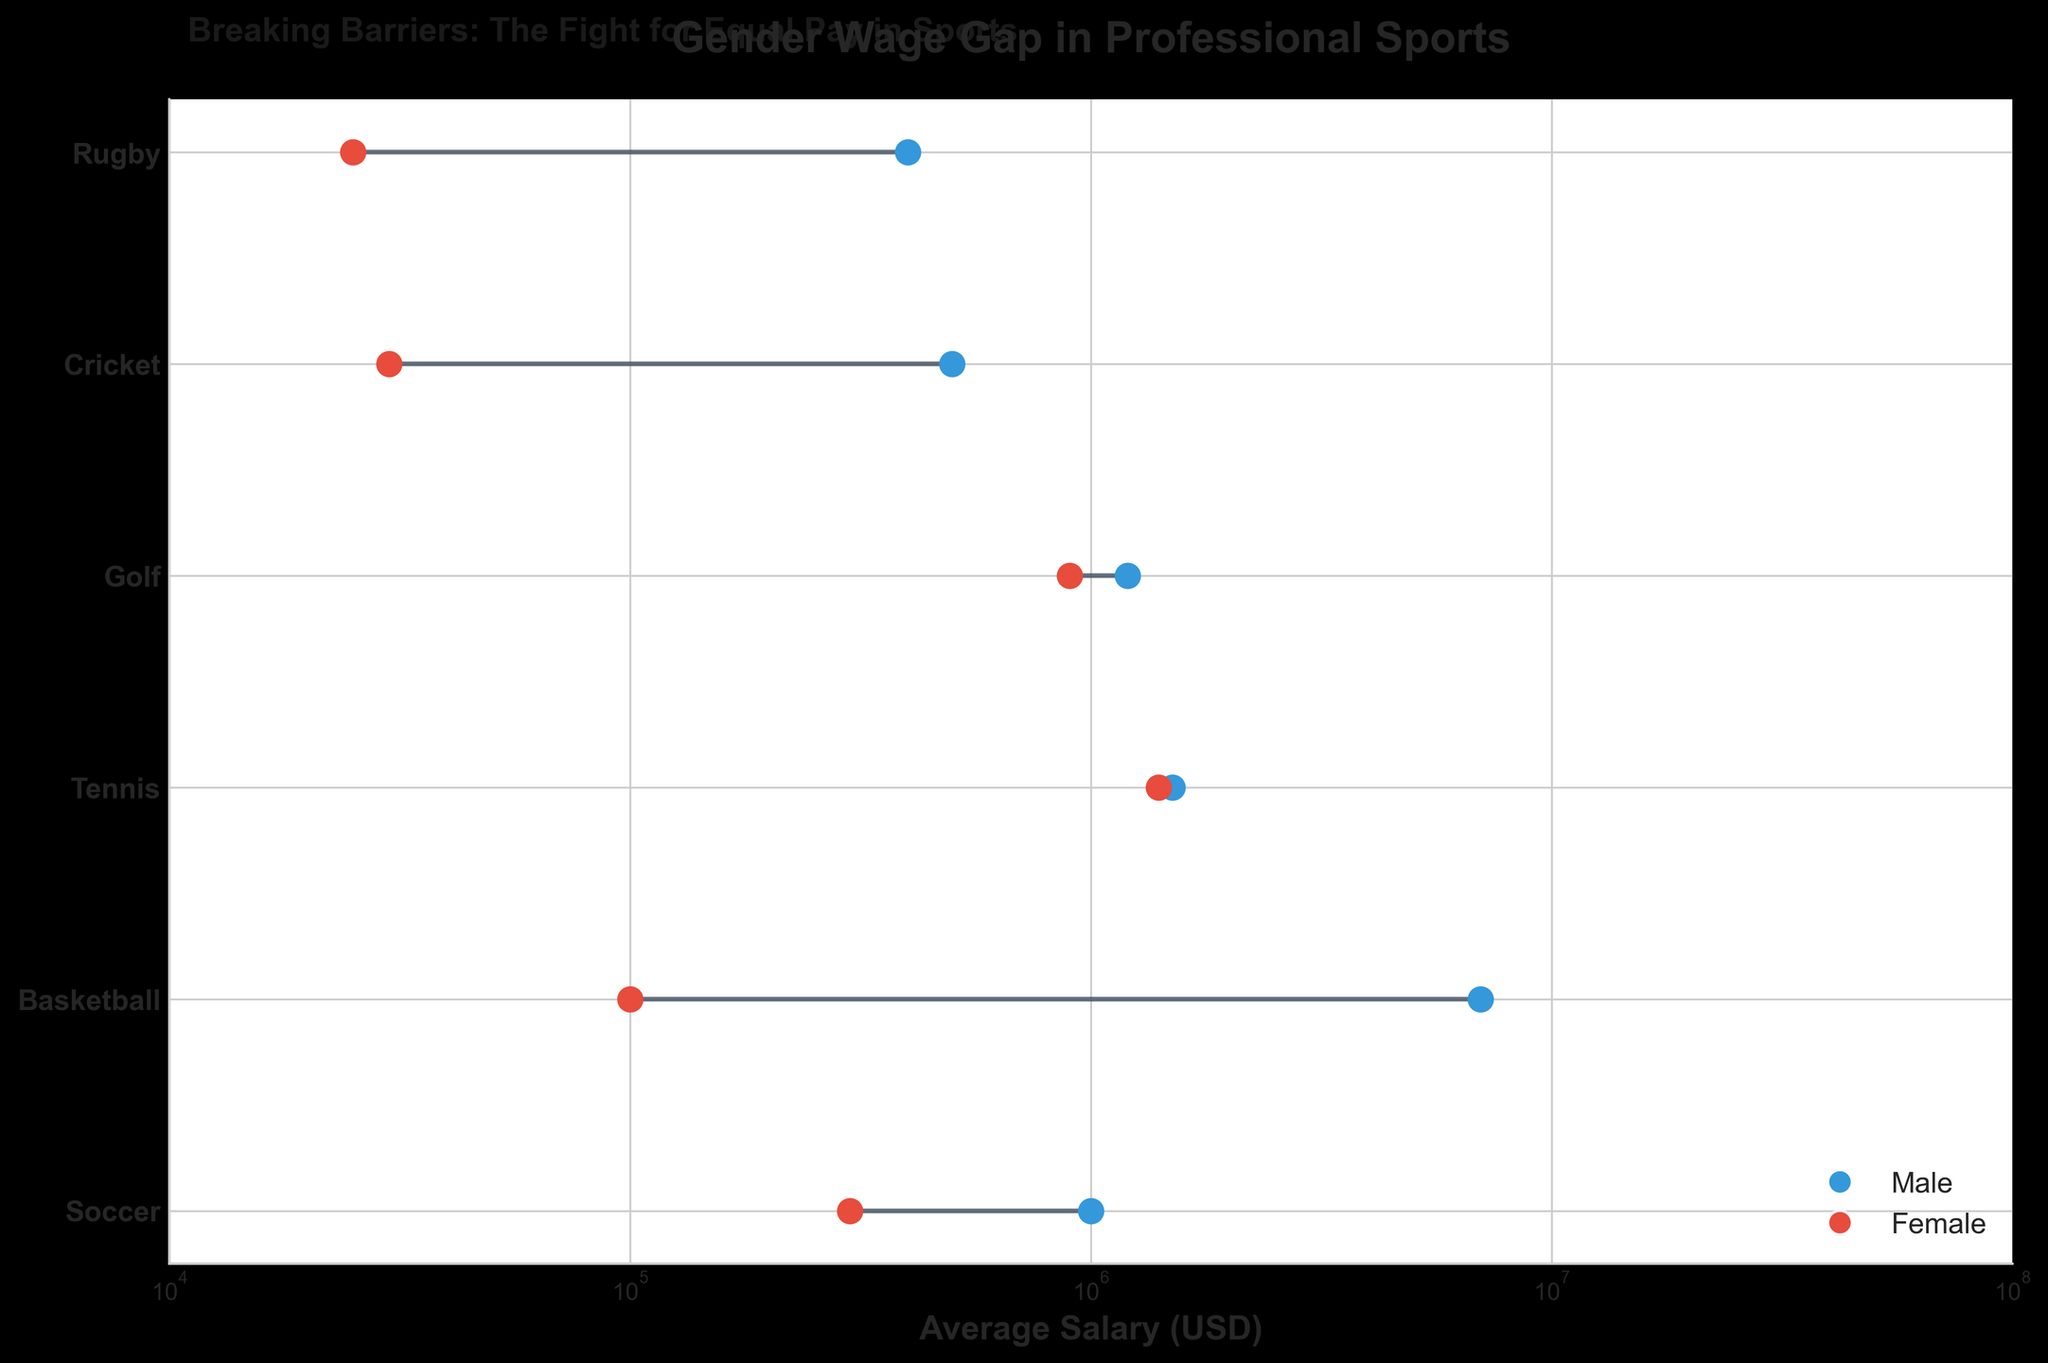Which sport has the smallest gender wage gap? By looking at the closeness of the male and female salaries, Tennis has the smallest gap between $1,500,000 (male) and $1,400,000 (female).
Answer: Tennis What is the title of the plot? The title is written above the plot to describe the subject matter, reading "Gender Wage Gap in Professional Sports".
Answer: Gender Wage Gap in Professional Sports Which sport shows the highest male average salary? By comparing the lengths of the blue lines along the x-axis, Basketball has the highest male salary at $7,000,000.
Answer: Basketball What is the color used to represent female athletes? The red scatter points and lines in the plot represent female athletes.
Answer: Red How much greater is the average male salary in Soccer compared to the average female salary? The male average salary in Soccer is $1,000,000, and the female average salary is $300,000. The difference is $1,000,000 - $300,000 = $700,000.
Answer: $700,000 What is the comparison of female salaries in Basketball and Soccer? The female salary in Basketball is $100,000, and in Soccer, it is $300,000. Soccer salaries are greater, so $300,000 > $100,000.
Answer: Soccer salaries are higher What axis scaling is used in the plot? The x-axis appears compressed for numbers and shows non-linear scaling, indicating a logarithmic scale.
Answer: Logarithmic Which sport has the largest gender wage gap? The largest gap can be identified where the male and female data points are furthest apart, found in Basketball where the difference is $6,900,000 ($7,000,000 - $100,000).
Answer: Basketball How does Rugby's male salary compare to its female average salary? Rugby has male average salary $400,000 and female $25,000. The male salary is significantly higher: $400,000 > $25,000.
Answer: Male salary is higher Which gender shows the dots colored in blue? By observing the legend and the colors, blue dots represent the male salaries.
Answer: Male 